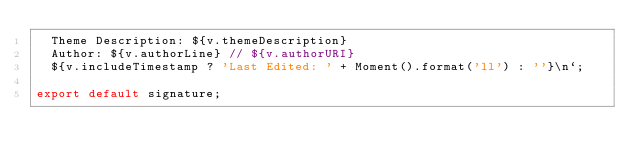<code> <loc_0><loc_0><loc_500><loc_500><_JavaScript_>  Theme Description: ${v.themeDescription}
  Author: ${v.authorLine} // ${v.authorURI}
  ${v.includeTimestamp ? 'Last Edited: ' + Moment().format('ll') : ''}\n`;

export default signature;
</code> 